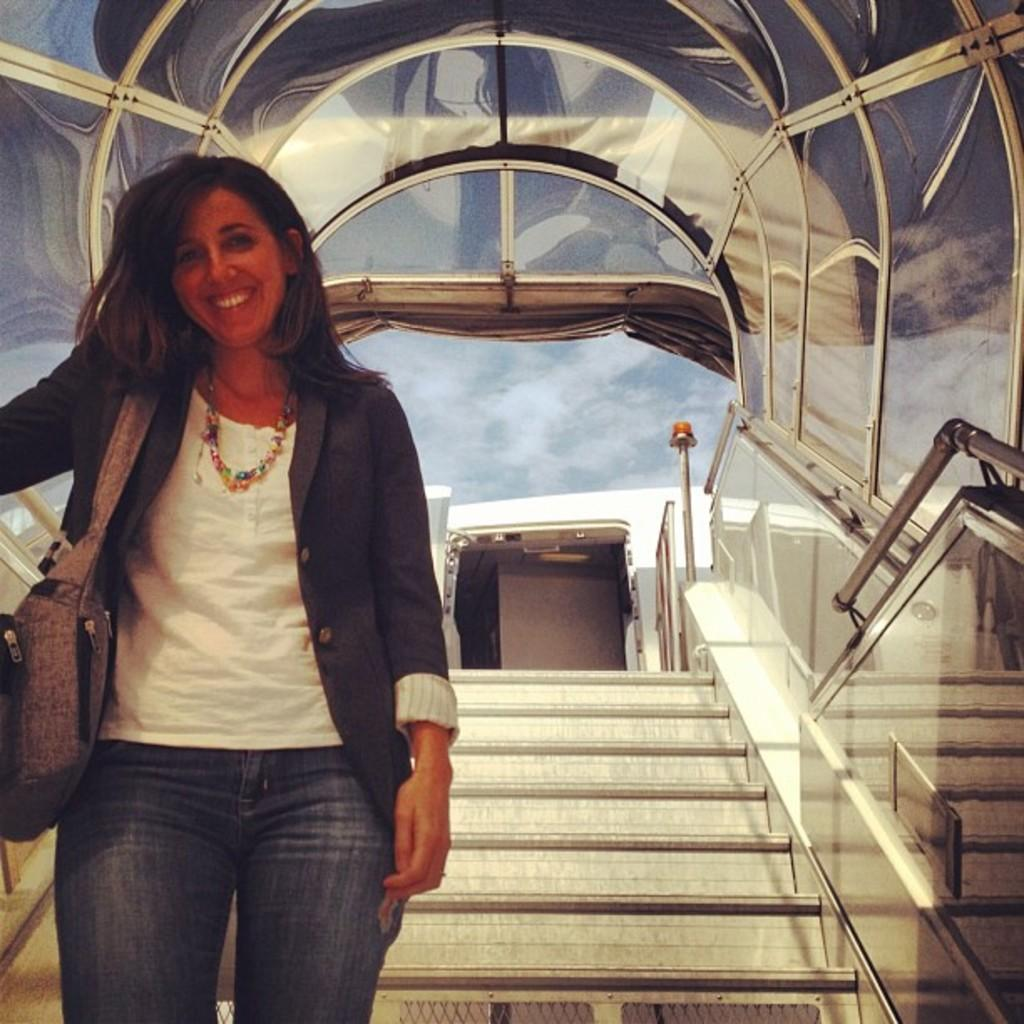What is the woman doing in the foreground of the picture? The woman is standing on a staircase in the foreground of the picture. Where is the woman located in relation to the walkway? The woman is in a walkway. What can be seen in the background of the image? There is a pole and a building in the background of the image. What is the condition of the sky in the picture? The sky is partially cloudy. What type of range can be seen in the image? There is no range present in the image. What border separates the walkway from the building in the image? There is no border visible in the image; the woman is simply standing in a walkway with a building in the background. 